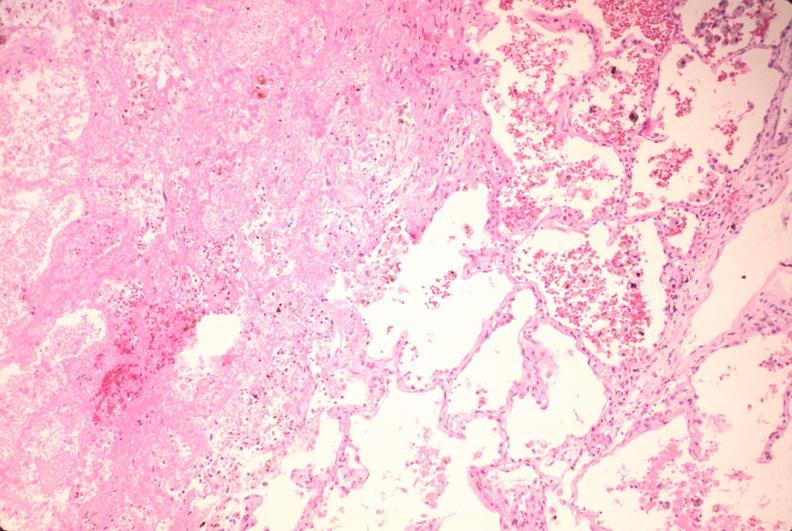does surface show lung, infarct, acute and organized?
Answer the question using a single word or phrase. No 